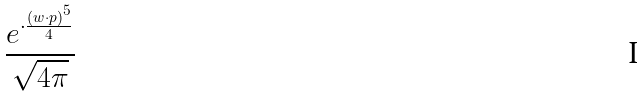<formula> <loc_0><loc_0><loc_500><loc_500>\frac { e ^ { \cdot \frac { ( w \cdot p ) ^ { 5 } } { 4 } } } { \sqrt { 4 \pi } }</formula> 